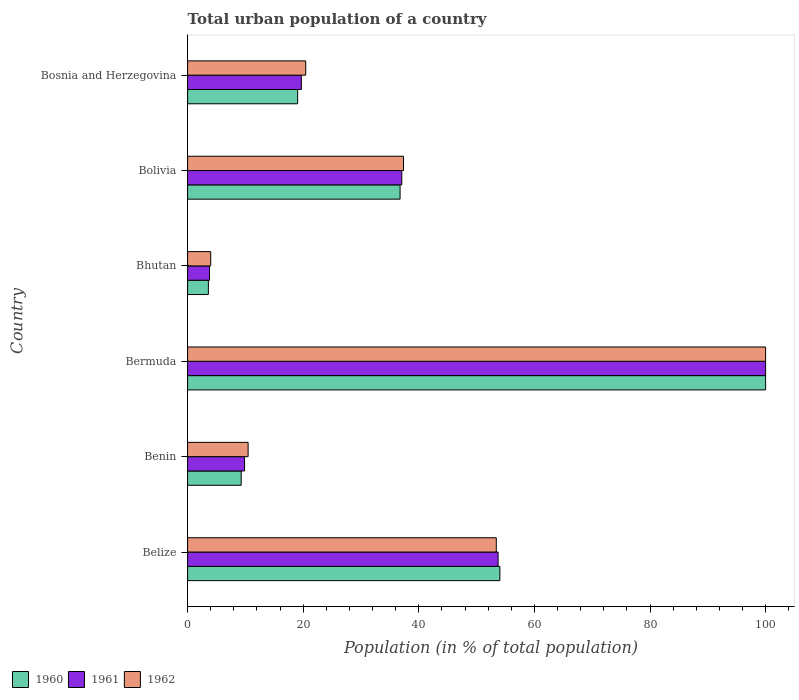How many different coloured bars are there?
Your answer should be very brief. 3. How many groups of bars are there?
Your answer should be very brief. 6. Are the number of bars per tick equal to the number of legend labels?
Offer a very short reply. Yes. How many bars are there on the 1st tick from the top?
Provide a succinct answer. 3. How many bars are there on the 5th tick from the bottom?
Keep it short and to the point. 3. What is the label of the 1st group of bars from the top?
Give a very brief answer. Bosnia and Herzegovina. What is the urban population in 1961 in Bolivia?
Your answer should be very brief. 37.06. Across all countries, what is the minimum urban population in 1960?
Give a very brief answer. 3.6. In which country was the urban population in 1961 maximum?
Your answer should be very brief. Bermuda. In which country was the urban population in 1961 minimum?
Your answer should be compact. Bhutan. What is the total urban population in 1961 in the graph?
Offer a very short reply. 224.11. What is the difference between the urban population in 1960 in Belize and that in Bosnia and Herzegovina?
Your answer should be compact. 34.99. What is the difference between the urban population in 1961 in Bolivia and the urban population in 1960 in Bhutan?
Offer a terse response. 33.46. What is the average urban population in 1960 per country?
Your answer should be compact. 37.12. What is the difference between the urban population in 1960 and urban population in 1962 in Bhutan?
Make the answer very short. -0.4. In how many countries, is the urban population in 1962 greater than 88 %?
Your answer should be very brief. 1. What is the ratio of the urban population in 1961 in Bolivia to that in Bosnia and Herzegovina?
Offer a very short reply. 1.88. Is the urban population in 1961 in Bhutan less than that in Bosnia and Herzegovina?
Make the answer very short. Yes. What is the difference between the highest and the second highest urban population in 1961?
Offer a terse response. 46.28. What is the difference between the highest and the lowest urban population in 1960?
Give a very brief answer. 96.4. In how many countries, is the urban population in 1961 greater than the average urban population in 1961 taken over all countries?
Your answer should be very brief. 2. Is the sum of the urban population in 1961 in Benin and Bosnia and Herzegovina greater than the maximum urban population in 1960 across all countries?
Your response must be concise. No. What does the 2nd bar from the bottom in Bolivia represents?
Make the answer very short. 1961. Is it the case that in every country, the sum of the urban population in 1960 and urban population in 1962 is greater than the urban population in 1961?
Offer a very short reply. Yes. What is the difference between two consecutive major ticks on the X-axis?
Make the answer very short. 20. What is the title of the graph?
Your answer should be compact. Total urban population of a country. Does "1960" appear as one of the legend labels in the graph?
Offer a terse response. Yes. What is the label or title of the X-axis?
Offer a terse response. Population (in % of total population). What is the Population (in % of total population) in 1960 in Belize?
Give a very brief answer. 54.03. What is the Population (in % of total population) of 1961 in Belize?
Provide a short and direct response. 53.72. What is the Population (in % of total population) of 1962 in Belize?
Your response must be concise. 53.41. What is the Population (in % of total population) in 1960 in Benin?
Offer a very short reply. 9.28. What is the Population (in % of total population) in 1961 in Benin?
Provide a short and direct response. 9.86. What is the Population (in % of total population) in 1962 in Benin?
Make the answer very short. 10.47. What is the Population (in % of total population) of 1960 in Bhutan?
Ensure brevity in your answer.  3.6. What is the Population (in % of total population) of 1961 in Bhutan?
Offer a terse response. 3.79. What is the Population (in % of total population) in 1962 in Bhutan?
Your response must be concise. 4. What is the Population (in % of total population) in 1960 in Bolivia?
Ensure brevity in your answer.  36.76. What is the Population (in % of total population) in 1961 in Bolivia?
Give a very brief answer. 37.06. What is the Population (in % of total population) in 1962 in Bolivia?
Offer a terse response. 37.36. What is the Population (in % of total population) in 1960 in Bosnia and Herzegovina?
Keep it short and to the point. 19.04. What is the Population (in % of total population) of 1961 in Bosnia and Herzegovina?
Your answer should be compact. 19.69. What is the Population (in % of total population) in 1962 in Bosnia and Herzegovina?
Make the answer very short. 20.44. Across all countries, what is the maximum Population (in % of total population) of 1960?
Offer a terse response. 100. Across all countries, what is the minimum Population (in % of total population) in 1960?
Ensure brevity in your answer.  3.6. Across all countries, what is the minimum Population (in % of total population) of 1961?
Make the answer very short. 3.79. Across all countries, what is the minimum Population (in % of total population) in 1962?
Offer a very short reply. 4. What is the total Population (in % of total population) in 1960 in the graph?
Make the answer very short. 222.7. What is the total Population (in % of total population) of 1961 in the graph?
Offer a very short reply. 224.11. What is the total Population (in % of total population) of 1962 in the graph?
Ensure brevity in your answer.  225.67. What is the difference between the Population (in % of total population) of 1960 in Belize and that in Benin?
Make the answer very short. 44.75. What is the difference between the Population (in % of total population) in 1961 in Belize and that in Benin?
Your response must be concise. 43.86. What is the difference between the Population (in % of total population) in 1962 in Belize and that in Benin?
Offer a very short reply. 42.94. What is the difference between the Population (in % of total population) of 1960 in Belize and that in Bermuda?
Your answer should be compact. -45.97. What is the difference between the Population (in % of total population) in 1961 in Belize and that in Bermuda?
Offer a very short reply. -46.28. What is the difference between the Population (in % of total population) of 1962 in Belize and that in Bermuda?
Your answer should be compact. -46.59. What is the difference between the Population (in % of total population) of 1960 in Belize and that in Bhutan?
Offer a terse response. 50.43. What is the difference between the Population (in % of total population) in 1961 in Belize and that in Bhutan?
Make the answer very short. 49.93. What is the difference between the Population (in % of total population) in 1962 in Belize and that in Bhutan?
Give a very brief answer. 49.41. What is the difference between the Population (in % of total population) of 1960 in Belize and that in Bolivia?
Give a very brief answer. 17.27. What is the difference between the Population (in % of total population) of 1961 in Belize and that in Bolivia?
Your response must be concise. 16.66. What is the difference between the Population (in % of total population) in 1962 in Belize and that in Bolivia?
Your answer should be compact. 16.05. What is the difference between the Population (in % of total population) in 1960 in Belize and that in Bosnia and Herzegovina?
Provide a succinct answer. 34.99. What is the difference between the Population (in % of total population) of 1961 in Belize and that in Bosnia and Herzegovina?
Ensure brevity in your answer.  34.03. What is the difference between the Population (in % of total population) of 1962 in Belize and that in Bosnia and Herzegovina?
Your answer should be compact. 32.97. What is the difference between the Population (in % of total population) of 1960 in Benin and that in Bermuda?
Give a very brief answer. -90.72. What is the difference between the Population (in % of total population) of 1961 in Benin and that in Bermuda?
Your answer should be very brief. -90.14. What is the difference between the Population (in % of total population) of 1962 in Benin and that in Bermuda?
Provide a short and direct response. -89.53. What is the difference between the Population (in % of total population) in 1960 in Benin and that in Bhutan?
Provide a succinct answer. 5.68. What is the difference between the Population (in % of total population) in 1961 in Benin and that in Bhutan?
Keep it short and to the point. 6.06. What is the difference between the Population (in % of total population) in 1962 in Benin and that in Bhutan?
Your answer should be very brief. 6.47. What is the difference between the Population (in % of total population) of 1960 in Benin and that in Bolivia?
Provide a succinct answer. -27.49. What is the difference between the Population (in % of total population) in 1961 in Benin and that in Bolivia?
Offer a very short reply. -27.2. What is the difference between the Population (in % of total population) in 1962 in Benin and that in Bolivia?
Make the answer very short. -26.89. What is the difference between the Population (in % of total population) in 1960 in Benin and that in Bosnia and Herzegovina?
Ensure brevity in your answer.  -9.77. What is the difference between the Population (in % of total population) in 1961 in Benin and that in Bosnia and Herzegovina?
Provide a succinct answer. -9.83. What is the difference between the Population (in % of total population) in 1962 in Benin and that in Bosnia and Herzegovina?
Offer a very short reply. -9.97. What is the difference between the Population (in % of total population) of 1960 in Bermuda and that in Bhutan?
Keep it short and to the point. 96.4. What is the difference between the Population (in % of total population) in 1961 in Bermuda and that in Bhutan?
Your answer should be compact. 96.21. What is the difference between the Population (in % of total population) of 1962 in Bermuda and that in Bhutan?
Keep it short and to the point. 96. What is the difference between the Population (in % of total population) in 1960 in Bermuda and that in Bolivia?
Provide a succinct answer. 63.24. What is the difference between the Population (in % of total population) of 1961 in Bermuda and that in Bolivia?
Offer a very short reply. 62.94. What is the difference between the Population (in % of total population) of 1962 in Bermuda and that in Bolivia?
Provide a short and direct response. 62.64. What is the difference between the Population (in % of total population) in 1960 in Bermuda and that in Bosnia and Herzegovina?
Offer a very short reply. 80.96. What is the difference between the Population (in % of total population) in 1961 in Bermuda and that in Bosnia and Herzegovina?
Give a very brief answer. 80.31. What is the difference between the Population (in % of total population) of 1962 in Bermuda and that in Bosnia and Herzegovina?
Provide a succinct answer. 79.56. What is the difference between the Population (in % of total population) in 1960 in Bhutan and that in Bolivia?
Offer a terse response. -33.17. What is the difference between the Population (in % of total population) in 1961 in Bhutan and that in Bolivia?
Your answer should be compact. -33.27. What is the difference between the Population (in % of total population) of 1962 in Bhutan and that in Bolivia?
Ensure brevity in your answer.  -33.36. What is the difference between the Population (in % of total population) in 1960 in Bhutan and that in Bosnia and Herzegovina?
Your answer should be very brief. -15.44. What is the difference between the Population (in % of total population) of 1961 in Bhutan and that in Bosnia and Herzegovina?
Keep it short and to the point. -15.89. What is the difference between the Population (in % of total population) in 1962 in Bhutan and that in Bosnia and Herzegovina?
Make the answer very short. -16.44. What is the difference between the Population (in % of total population) of 1960 in Bolivia and that in Bosnia and Herzegovina?
Your answer should be very brief. 17.72. What is the difference between the Population (in % of total population) in 1961 in Bolivia and that in Bosnia and Herzegovina?
Provide a succinct answer. 17.37. What is the difference between the Population (in % of total population) of 1962 in Bolivia and that in Bosnia and Herzegovina?
Give a very brief answer. 16.92. What is the difference between the Population (in % of total population) in 1960 in Belize and the Population (in % of total population) in 1961 in Benin?
Your response must be concise. 44.17. What is the difference between the Population (in % of total population) of 1960 in Belize and the Population (in % of total population) of 1962 in Benin?
Provide a succinct answer. 43.56. What is the difference between the Population (in % of total population) of 1961 in Belize and the Population (in % of total population) of 1962 in Benin?
Give a very brief answer. 43.25. What is the difference between the Population (in % of total population) of 1960 in Belize and the Population (in % of total population) of 1961 in Bermuda?
Your answer should be compact. -45.97. What is the difference between the Population (in % of total population) of 1960 in Belize and the Population (in % of total population) of 1962 in Bermuda?
Offer a very short reply. -45.97. What is the difference between the Population (in % of total population) of 1961 in Belize and the Population (in % of total population) of 1962 in Bermuda?
Your response must be concise. -46.28. What is the difference between the Population (in % of total population) in 1960 in Belize and the Population (in % of total population) in 1961 in Bhutan?
Give a very brief answer. 50.24. What is the difference between the Population (in % of total population) of 1960 in Belize and the Population (in % of total population) of 1962 in Bhutan?
Your response must be concise. 50.03. What is the difference between the Population (in % of total population) in 1961 in Belize and the Population (in % of total population) in 1962 in Bhutan?
Give a very brief answer. 49.72. What is the difference between the Population (in % of total population) of 1960 in Belize and the Population (in % of total population) of 1961 in Bolivia?
Provide a short and direct response. 16.97. What is the difference between the Population (in % of total population) of 1960 in Belize and the Population (in % of total population) of 1962 in Bolivia?
Give a very brief answer. 16.67. What is the difference between the Population (in % of total population) of 1961 in Belize and the Population (in % of total population) of 1962 in Bolivia?
Ensure brevity in your answer.  16.36. What is the difference between the Population (in % of total population) in 1960 in Belize and the Population (in % of total population) in 1961 in Bosnia and Herzegovina?
Make the answer very short. 34.34. What is the difference between the Population (in % of total population) in 1960 in Belize and the Population (in % of total population) in 1962 in Bosnia and Herzegovina?
Your answer should be compact. 33.59. What is the difference between the Population (in % of total population) of 1961 in Belize and the Population (in % of total population) of 1962 in Bosnia and Herzegovina?
Give a very brief answer. 33.28. What is the difference between the Population (in % of total population) of 1960 in Benin and the Population (in % of total population) of 1961 in Bermuda?
Your response must be concise. -90.72. What is the difference between the Population (in % of total population) of 1960 in Benin and the Population (in % of total population) of 1962 in Bermuda?
Provide a succinct answer. -90.72. What is the difference between the Population (in % of total population) in 1961 in Benin and the Population (in % of total population) in 1962 in Bermuda?
Keep it short and to the point. -90.14. What is the difference between the Population (in % of total population) of 1960 in Benin and the Population (in % of total population) of 1961 in Bhutan?
Make the answer very short. 5.48. What is the difference between the Population (in % of total population) in 1960 in Benin and the Population (in % of total population) in 1962 in Bhutan?
Your response must be concise. 5.28. What is the difference between the Population (in % of total population) of 1961 in Benin and the Population (in % of total population) of 1962 in Bhutan?
Your response must be concise. 5.86. What is the difference between the Population (in % of total population) of 1960 in Benin and the Population (in % of total population) of 1961 in Bolivia?
Your answer should be very brief. -27.78. What is the difference between the Population (in % of total population) in 1960 in Benin and the Population (in % of total population) in 1962 in Bolivia?
Give a very brief answer. -28.08. What is the difference between the Population (in % of total population) in 1961 in Benin and the Population (in % of total population) in 1962 in Bolivia?
Make the answer very short. -27.5. What is the difference between the Population (in % of total population) in 1960 in Benin and the Population (in % of total population) in 1961 in Bosnia and Herzegovina?
Provide a succinct answer. -10.41. What is the difference between the Population (in % of total population) in 1960 in Benin and the Population (in % of total population) in 1962 in Bosnia and Herzegovina?
Your response must be concise. -11.16. What is the difference between the Population (in % of total population) of 1961 in Benin and the Population (in % of total population) of 1962 in Bosnia and Herzegovina?
Your answer should be very brief. -10.58. What is the difference between the Population (in % of total population) in 1960 in Bermuda and the Population (in % of total population) in 1961 in Bhutan?
Offer a very short reply. 96.21. What is the difference between the Population (in % of total population) of 1960 in Bermuda and the Population (in % of total population) of 1962 in Bhutan?
Ensure brevity in your answer.  96. What is the difference between the Population (in % of total population) in 1961 in Bermuda and the Population (in % of total population) in 1962 in Bhutan?
Your answer should be very brief. 96. What is the difference between the Population (in % of total population) of 1960 in Bermuda and the Population (in % of total population) of 1961 in Bolivia?
Provide a short and direct response. 62.94. What is the difference between the Population (in % of total population) of 1960 in Bermuda and the Population (in % of total population) of 1962 in Bolivia?
Give a very brief answer. 62.64. What is the difference between the Population (in % of total population) in 1961 in Bermuda and the Population (in % of total population) in 1962 in Bolivia?
Offer a terse response. 62.64. What is the difference between the Population (in % of total population) in 1960 in Bermuda and the Population (in % of total population) in 1961 in Bosnia and Herzegovina?
Provide a short and direct response. 80.31. What is the difference between the Population (in % of total population) of 1960 in Bermuda and the Population (in % of total population) of 1962 in Bosnia and Herzegovina?
Give a very brief answer. 79.56. What is the difference between the Population (in % of total population) in 1961 in Bermuda and the Population (in % of total population) in 1962 in Bosnia and Herzegovina?
Provide a short and direct response. 79.56. What is the difference between the Population (in % of total population) in 1960 in Bhutan and the Population (in % of total population) in 1961 in Bolivia?
Your answer should be compact. -33.46. What is the difference between the Population (in % of total population) of 1960 in Bhutan and the Population (in % of total population) of 1962 in Bolivia?
Keep it short and to the point. -33.76. What is the difference between the Population (in % of total population) of 1961 in Bhutan and the Population (in % of total population) of 1962 in Bolivia?
Keep it short and to the point. -33.56. What is the difference between the Population (in % of total population) of 1960 in Bhutan and the Population (in % of total population) of 1961 in Bosnia and Herzegovina?
Ensure brevity in your answer.  -16.09. What is the difference between the Population (in % of total population) in 1960 in Bhutan and the Population (in % of total population) in 1962 in Bosnia and Herzegovina?
Make the answer very short. -16.84. What is the difference between the Population (in % of total population) in 1961 in Bhutan and the Population (in % of total population) in 1962 in Bosnia and Herzegovina?
Ensure brevity in your answer.  -16.64. What is the difference between the Population (in % of total population) of 1960 in Bolivia and the Population (in % of total population) of 1961 in Bosnia and Herzegovina?
Provide a succinct answer. 17.08. What is the difference between the Population (in % of total population) in 1960 in Bolivia and the Population (in % of total population) in 1962 in Bosnia and Herzegovina?
Make the answer very short. 16.32. What is the difference between the Population (in % of total population) in 1961 in Bolivia and the Population (in % of total population) in 1962 in Bosnia and Herzegovina?
Give a very brief answer. 16.62. What is the average Population (in % of total population) of 1960 per country?
Your answer should be compact. 37.12. What is the average Population (in % of total population) in 1961 per country?
Your answer should be compact. 37.35. What is the average Population (in % of total population) of 1962 per country?
Keep it short and to the point. 37.61. What is the difference between the Population (in % of total population) of 1960 and Population (in % of total population) of 1961 in Belize?
Provide a succinct answer. 0.31. What is the difference between the Population (in % of total population) in 1960 and Population (in % of total population) in 1962 in Belize?
Offer a terse response. 0.62. What is the difference between the Population (in % of total population) in 1961 and Population (in % of total population) in 1962 in Belize?
Your answer should be very brief. 0.31. What is the difference between the Population (in % of total population) in 1960 and Population (in % of total population) in 1961 in Benin?
Make the answer very short. -0.58. What is the difference between the Population (in % of total population) in 1960 and Population (in % of total population) in 1962 in Benin?
Provide a short and direct response. -1.2. What is the difference between the Population (in % of total population) of 1961 and Population (in % of total population) of 1962 in Benin?
Make the answer very short. -0.61. What is the difference between the Population (in % of total population) of 1960 and Population (in % of total population) of 1961 in Bermuda?
Give a very brief answer. 0. What is the difference between the Population (in % of total population) of 1960 and Population (in % of total population) of 1962 in Bermuda?
Provide a short and direct response. 0. What is the difference between the Population (in % of total population) in 1960 and Population (in % of total population) in 1961 in Bhutan?
Keep it short and to the point. -0.2. What is the difference between the Population (in % of total population) in 1960 and Population (in % of total population) in 1962 in Bhutan?
Give a very brief answer. -0.4. What is the difference between the Population (in % of total population) of 1961 and Population (in % of total population) of 1962 in Bhutan?
Give a very brief answer. -0.21. What is the difference between the Population (in % of total population) of 1960 and Population (in % of total population) of 1961 in Bolivia?
Your answer should be very brief. -0.3. What is the difference between the Population (in % of total population) of 1960 and Population (in % of total population) of 1962 in Bolivia?
Provide a short and direct response. -0.59. What is the difference between the Population (in % of total population) of 1961 and Population (in % of total population) of 1962 in Bolivia?
Keep it short and to the point. -0.3. What is the difference between the Population (in % of total population) in 1960 and Population (in % of total population) in 1961 in Bosnia and Herzegovina?
Your answer should be compact. -0.65. What is the difference between the Population (in % of total population) of 1960 and Population (in % of total population) of 1962 in Bosnia and Herzegovina?
Make the answer very short. -1.4. What is the difference between the Population (in % of total population) of 1961 and Population (in % of total population) of 1962 in Bosnia and Herzegovina?
Offer a terse response. -0.75. What is the ratio of the Population (in % of total population) of 1960 in Belize to that in Benin?
Give a very brief answer. 5.83. What is the ratio of the Population (in % of total population) in 1961 in Belize to that in Benin?
Offer a terse response. 5.45. What is the ratio of the Population (in % of total population) in 1962 in Belize to that in Benin?
Give a very brief answer. 5.1. What is the ratio of the Population (in % of total population) of 1960 in Belize to that in Bermuda?
Ensure brevity in your answer.  0.54. What is the ratio of the Population (in % of total population) in 1961 in Belize to that in Bermuda?
Ensure brevity in your answer.  0.54. What is the ratio of the Population (in % of total population) in 1962 in Belize to that in Bermuda?
Offer a very short reply. 0.53. What is the ratio of the Population (in % of total population) of 1960 in Belize to that in Bhutan?
Give a very brief answer. 15.02. What is the ratio of the Population (in % of total population) of 1961 in Belize to that in Bhutan?
Offer a very short reply. 14.17. What is the ratio of the Population (in % of total population) of 1962 in Belize to that in Bhutan?
Your answer should be compact. 13.36. What is the ratio of the Population (in % of total population) of 1960 in Belize to that in Bolivia?
Offer a very short reply. 1.47. What is the ratio of the Population (in % of total population) in 1961 in Belize to that in Bolivia?
Your response must be concise. 1.45. What is the ratio of the Population (in % of total population) of 1962 in Belize to that in Bolivia?
Make the answer very short. 1.43. What is the ratio of the Population (in % of total population) in 1960 in Belize to that in Bosnia and Herzegovina?
Make the answer very short. 2.84. What is the ratio of the Population (in % of total population) of 1961 in Belize to that in Bosnia and Herzegovina?
Keep it short and to the point. 2.73. What is the ratio of the Population (in % of total population) in 1962 in Belize to that in Bosnia and Herzegovina?
Provide a short and direct response. 2.61. What is the ratio of the Population (in % of total population) in 1960 in Benin to that in Bermuda?
Give a very brief answer. 0.09. What is the ratio of the Population (in % of total population) in 1961 in Benin to that in Bermuda?
Your response must be concise. 0.1. What is the ratio of the Population (in % of total population) in 1962 in Benin to that in Bermuda?
Provide a succinct answer. 0.1. What is the ratio of the Population (in % of total population) of 1960 in Benin to that in Bhutan?
Your answer should be compact. 2.58. What is the ratio of the Population (in % of total population) in 1961 in Benin to that in Bhutan?
Give a very brief answer. 2.6. What is the ratio of the Population (in % of total population) in 1962 in Benin to that in Bhutan?
Your response must be concise. 2.62. What is the ratio of the Population (in % of total population) in 1960 in Benin to that in Bolivia?
Provide a short and direct response. 0.25. What is the ratio of the Population (in % of total population) of 1961 in Benin to that in Bolivia?
Your response must be concise. 0.27. What is the ratio of the Population (in % of total population) in 1962 in Benin to that in Bolivia?
Keep it short and to the point. 0.28. What is the ratio of the Population (in % of total population) in 1960 in Benin to that in Bosnia and Herzegovina?
Your answer should be very brief. 0.49. What is the ratio of the Population (in % of total population) in 1961 in Benin to that in Bosnia and Herzegovina?
Your answer should be very brief. 0.5. What is the ratio of the Population (in % of total population) in 1962 in Benin to that in Bosnia and Herzegovina?
Offer a very short reply. 0.51. What is the ratio of the Population (in % of total population) in 1960 in Bermuda to that in Bhutan?
Keep it short and to the point. 27.81. What is the ratio of the Population (in % of total population) of 1961 in Bermuda to that in Bhutan?
Your answer should be compact. 26.37. What is the ratio of the Population (in % of total population) of 1962 in Bermuda to that in Bhutan?
Ensure brevity in your answer.  25.01. What is the ratio of the Population (in % of total population) of 1960 in Bermuda to that in Bolivia?
Provide a short and direct response. 2.72. What is the ratio of the Population (in % of total population) in 1961 in Bermuda to that in Bolivia?
Offer a terse response. 2.7. What is the ratio of the Population (in % of total population) of 1962 in Bermuda to that in Bolivia?
Make the answer very short. 2.68. What is the ratio of the Population (in % of total population) in 1960 in Bermuda to that in Bosnia and Herzegovina?
Offer a terse response. 5.25. What is the ratio of the Population (in % of total population) in 1961 in Bermuda to that in Bosnia and Herzegovina?
Make the answer very short. 5.08. What is the ratio of the Population (in % of total population) in 1962 in Bermuda to that in Bosnia and Herzegovina?
Provide a short and direct response. 4.89. What is the ratio of the Population (in % of total population) of 1960 in Bhutan to that in Bolivia?
Your answer should be compact. 0.1. What is the ratio of the Population (in % of total population) in 1961 in Bhutan to that in Bolivia?
Your response must be concise. 0.1. What is the ratio of the Population (in % of total population) in 1962 in Bhutan to that in Bolivia?
Your answer should be compact. 0.11. What is the ratio of the Population (in % of total population) of 1960 in Bhutan to that in Bosnia and Herzegovina?
Offer a very short reply. 0.19. What is the ratio of the Population (in % of total population) of 1961 in Bhutan to that in Bosnia and Herzegovina?
Keep it short and to the point. 0.19. What is the ratio of the Population (in % of total population) in 1962 in Bhutan to that in Bosnia and Herzegovina?
Your response must be concise. 0.2. What is the ratio of the Population (in % of total population) of 1960 in Bolivia to that in Bosnia and Herzegovina?
Ensure brevity in your answer.  1.93. What is the ratio of the Population (in % of total population) in 1961 in Bolivia to that in Bosnia and Herzegovina?
Make the answer very short. 1.88. What is the ratio of the Population (in % of total population) of 1962 in Bolivia to that in Bosnia and Herzegovina?
Give a very brief answer. 1.83. What is the difference between the highest and the second highest Population (in % of total population) in 1960?
Give a very brief answer. 45.97. What is the difference between the highest and the second highest Population (in % of total population) of 1961?
Your answer should be very brief. 46.28. What is the difference between the highest and the second highest Population (in % of total population) in 1962?
Your response must be concise. 46.59. What is the difference between the highest and the lowest Population (in % of total population) in 1960?
Your answer should be very brief. 96.4. What is the difference between the highest and the lowest Population (in % of total population) of 1961?
Your answer should be very brief. 96.21. What is the difference between the highest and the lowest Population (in % of total population) of 1962?
Offer a terse response. 96. 